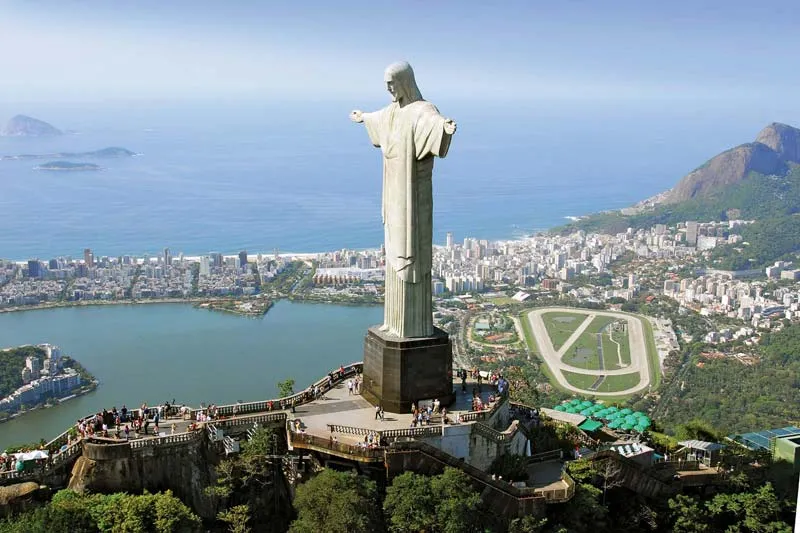Can you describe the main features of this image for me? The image features the iconic Christ the Redeemer statue in Rio de Janeiro, Brazil, sculpted by French artist Paul Landowski. This towering statue of Jesus Christ stands on the summit of Mount Corcovado, arms spread wide in a gesture symbolizing peace and openness. The statue is made from reinforced concrete and soapstone, and it's among the largest Art Deco-style sculptures in the world. Below, the panoramic view includes diverse architectural styles of Rio nested among verdant forests, flanked by the blue waters of the Atlantic Ocean. This spot, owing to its height and grandeur, offers one of the most comprehensive views of the city, showcasing its vibrant urban tapestry alongside natural beauty. Notably, it's also a UNESCO World Heritage site, beloved as a cultural symbol of Brazilian Christianity and the warmth of its people. The image captures a clear day, with the sun illuminating the city and the statue, casting soft shadows and highlighting the statue’s intricate details.  